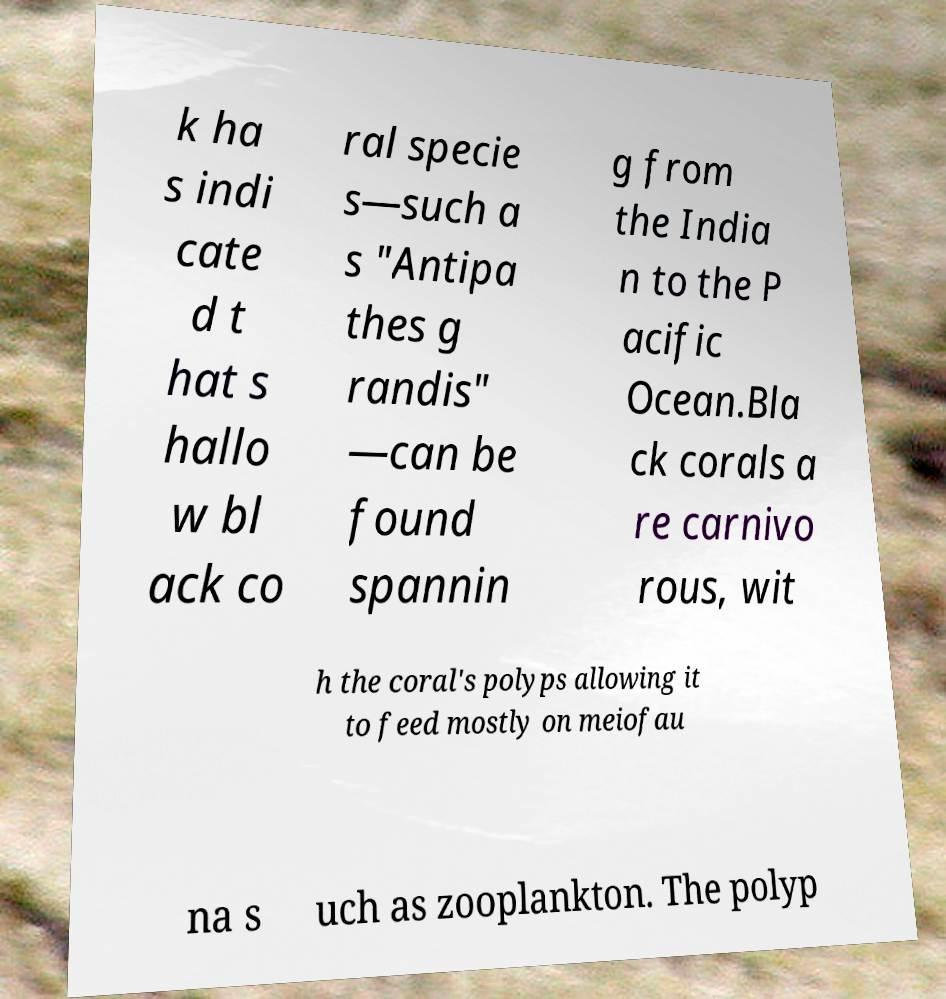Could you extract and type out the text from this image? k ha s indi cate d t hat s hallo w bl ack co ral specie s—such a s "Antipa thes g randis" —can be found spannin g from the India n to the P acific Ocean.Bla ck corals a re carnivo rous, wit h the coral's polyps allowing it to feed mostly on meiofau na s uch as zooplankton. The polyp 